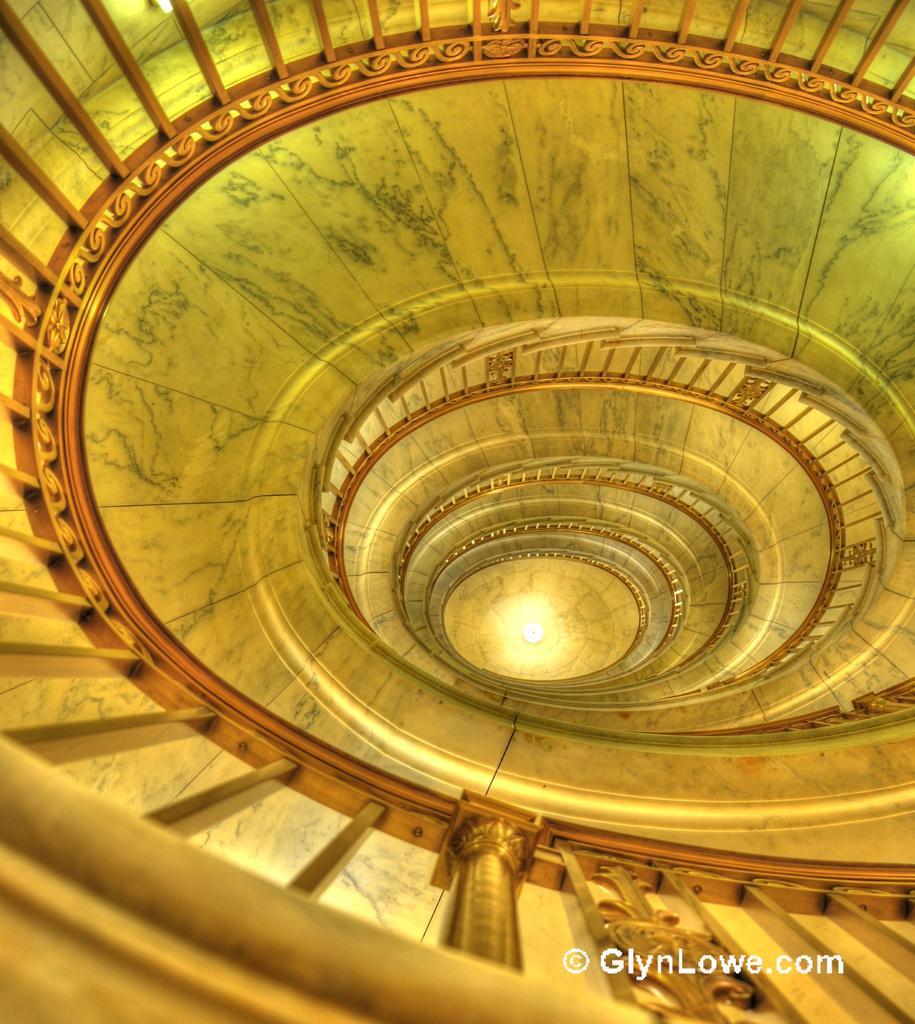In one or two sentences, can you explain what this image depicts? In the image we can see staircase. 